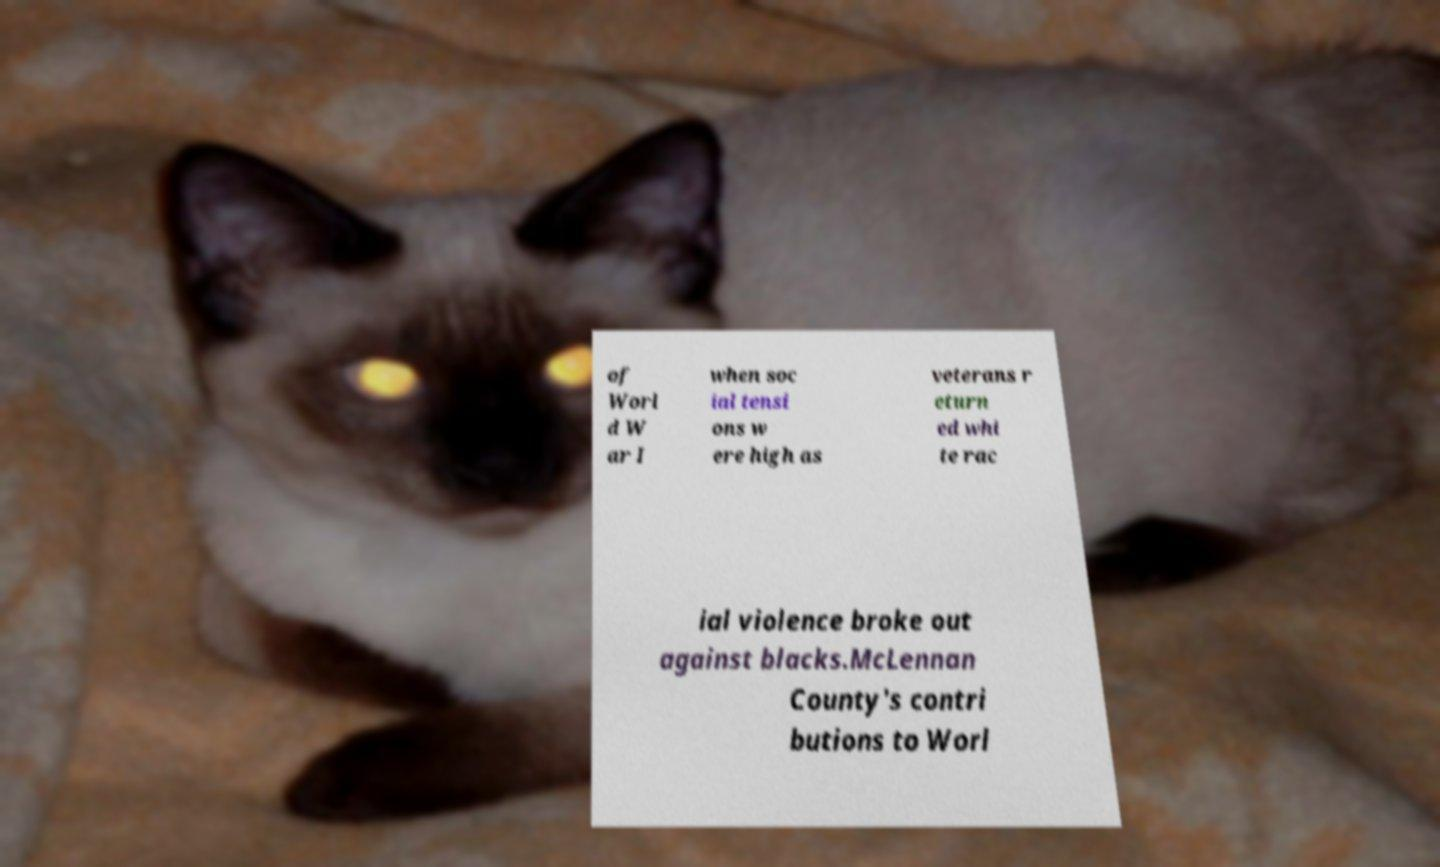Please identify and transcribe the text found in this image. of Worl d W ar I when soc ial tensi ons w ere high as veterans r eturn ed whi te rac ial violence broke out against blacks.McLennan County's contri butions to Worl 